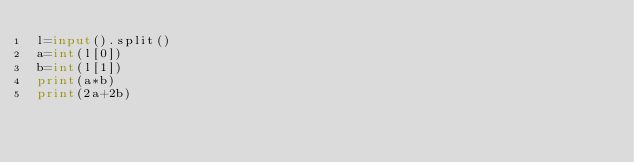Convert code to text. <code><loc_0><loc_0><loc_500><loc_500><_Python_>l=input().split()
a=int(l[0])
b=int(l[1])
print(a*b)
print(2a+2b)
</code> 